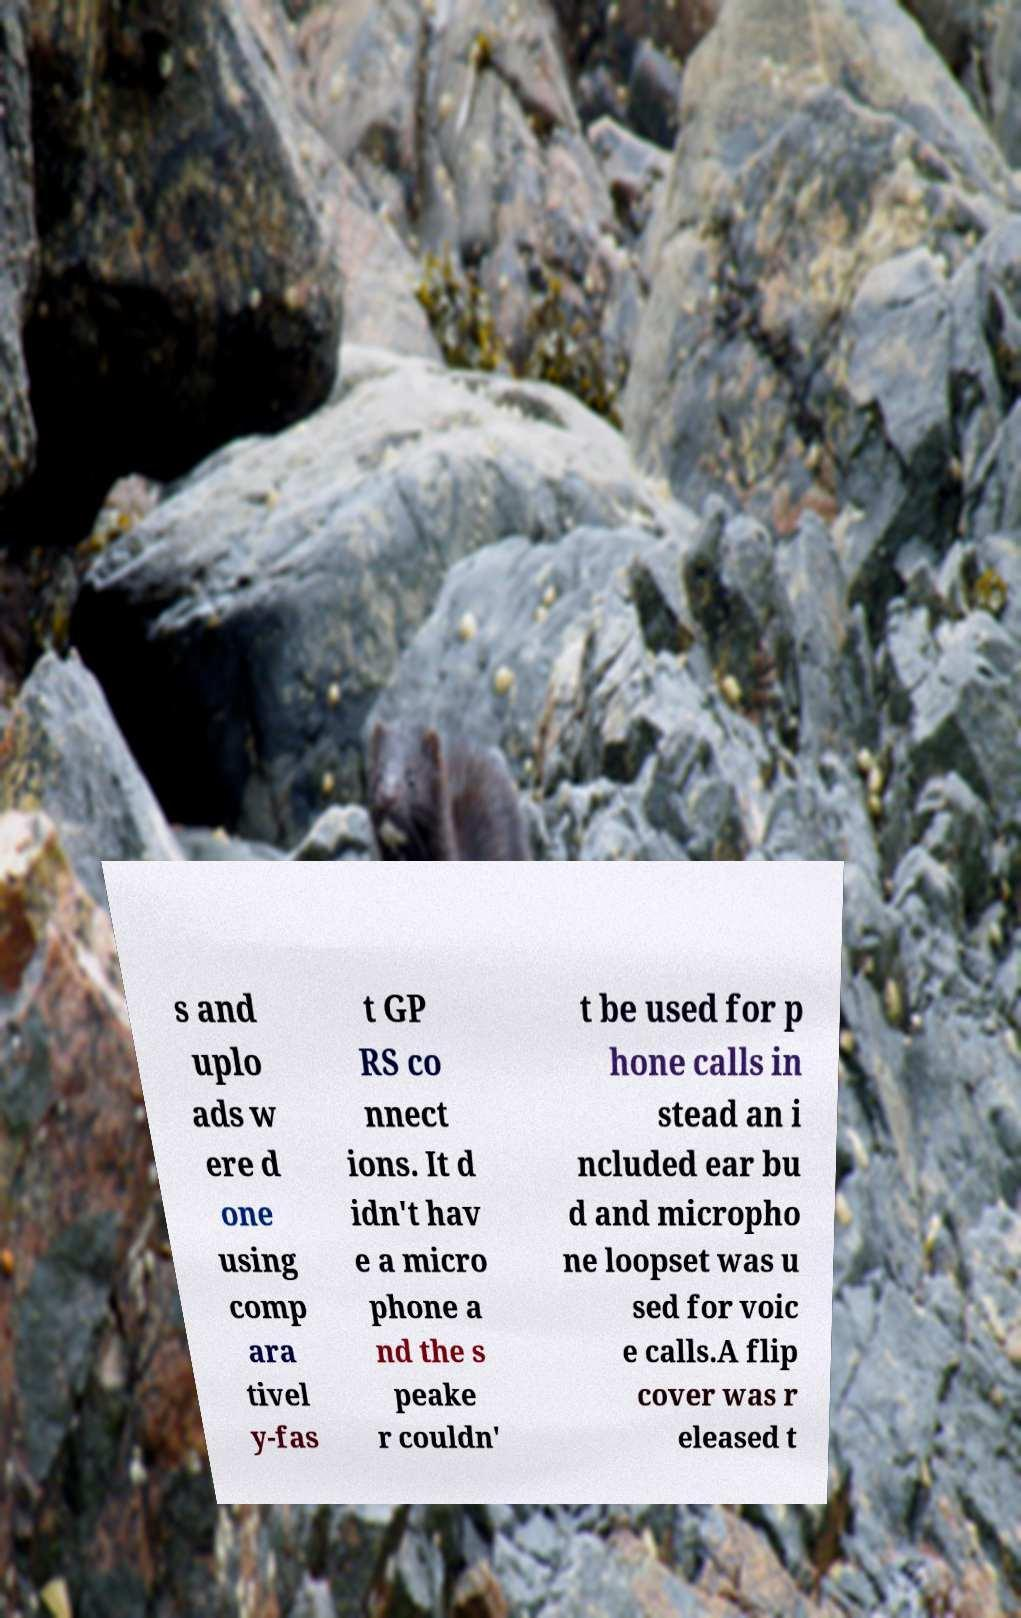Please identify and transcribe the text found in this image. s and uplo ads w ere d one using comp ara tivel y-fas t GP RS co nnect ions. It d idn't hav e a micro phone a nd the s peake r couldn' t be used for p hone calls in stead an i ncluded ear bu d and micropho ne loopset was u sed for voic e calls.A flip cover was r eleased t 